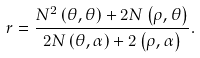Convert formula to latex. <formula><loc_0><loc_0><loc_500><loc_500>r = \frac { N ^ { 2 } \left ( \theta , \theta \right ) + 2 N \left ( \rho , \theta \right ) } { 2 N \left ( \theta , \alpha \right ) + 2 \left ( \rho , \alpha \right ) } .</formula> 